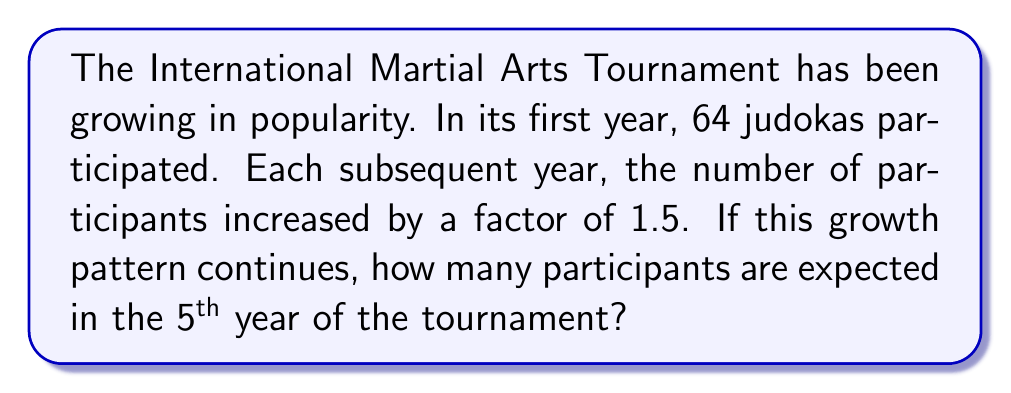Give your solution to this math problem. Let's approach this step-by-step:

1) We're dealing with a geometric sequence where:
   - Initial term, $a_1 = 64$
   - Common ratio, $r = 1.5$
   - We need to find the 5th term, $a_5$

2) The formula for the nth term of a geometric sequence is:
   $a_n = a_1 \cdot r^{n-1}$

3) Substituting our values:
   $a_5 = 64 \cdot (1.5)^{5-1}$
   $a_5 = 64 \cdot (1.5)^4$

4) Let's calculate $(1.5)^4$:
   $(1.5)^4 = 1.5 \cdot 1.5 \cdot 1.5 \cdot 1.5 = 5.0625$

5) Now, we can complete our calculation:
   $a_5 = 64 \cdot 5.0625 = 324$

Therefore, in the 5th year, we expect 324 participants.
Answer: 324 participants 